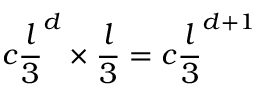Convert formula to latex. <formula><loc_0><loc_0><loc_500><loc_500>c \frac { l } { 3 } ^ { d } \times \frac { l } { 3 } = c \frac { l } { 3 } ^ { d + 1 }</formula> 